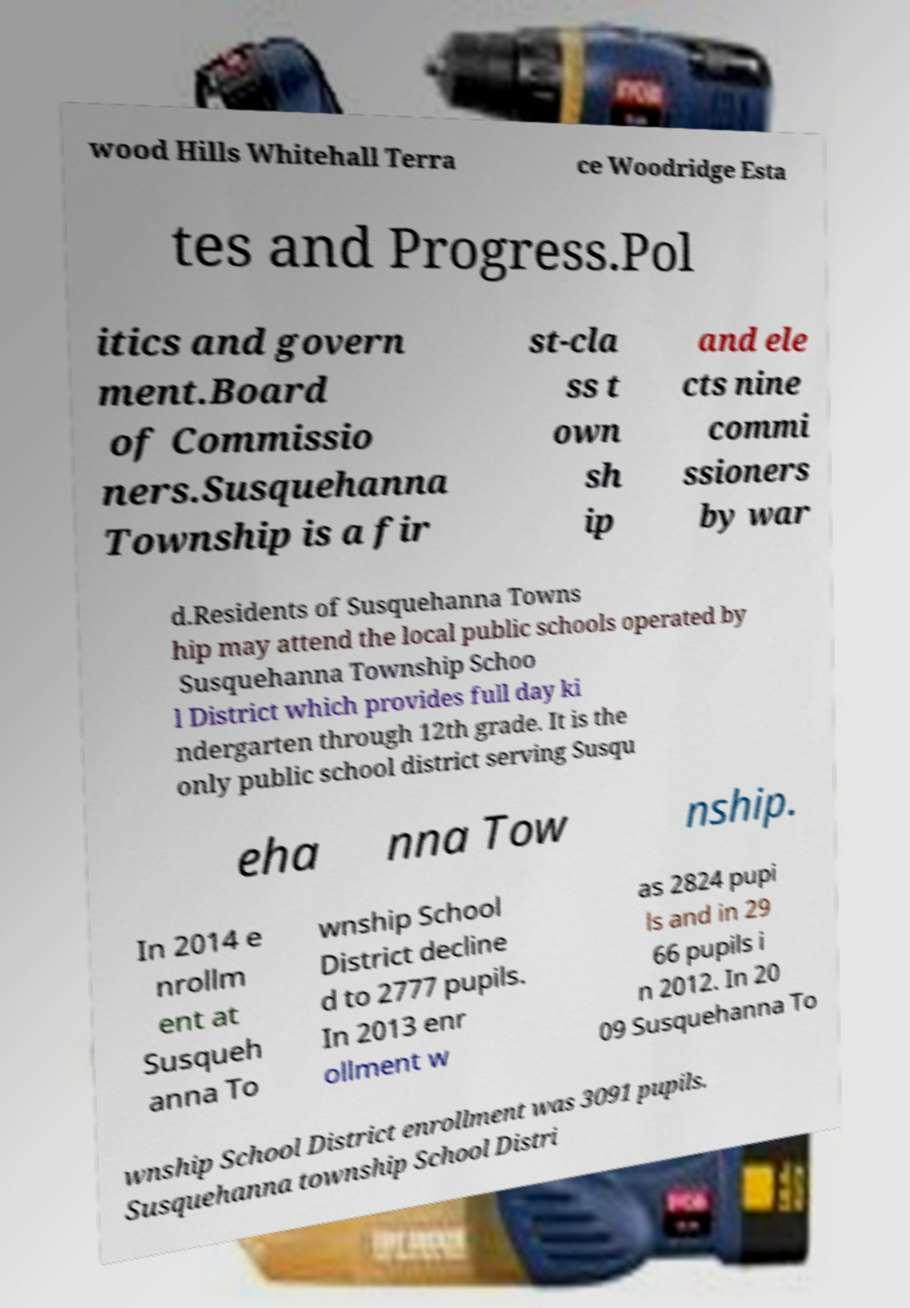I need the written content from this picture converted into text. Can you do that? wood Hills Whitehall Terra ce Woodridge Esta tes and Progress.Pol itics and govern ment.Board of Commissio ners.Susquehanna Township is a fir st-cla ss t own sh ip and ele cts nine commi ssioners by war d.Residents of Susquehanna Towns hip may attend the local public schools operated by Susquehanna Township Schoo l District which provides full day ki ndergarten through 12th grade. It is the only public school district serving Susqu eha nna Tow nship. In 2014 e nrollm ent at Susqueh anna To wnship School District decline d to 2777 pupils. In 2013 enr ollment w as 2824 pupi ls and in 29 66 pupils i n 2012. In 20 09 Susquehanna To wnship School District enrollment was 3091 pupils. Susquehanna township School Distri 